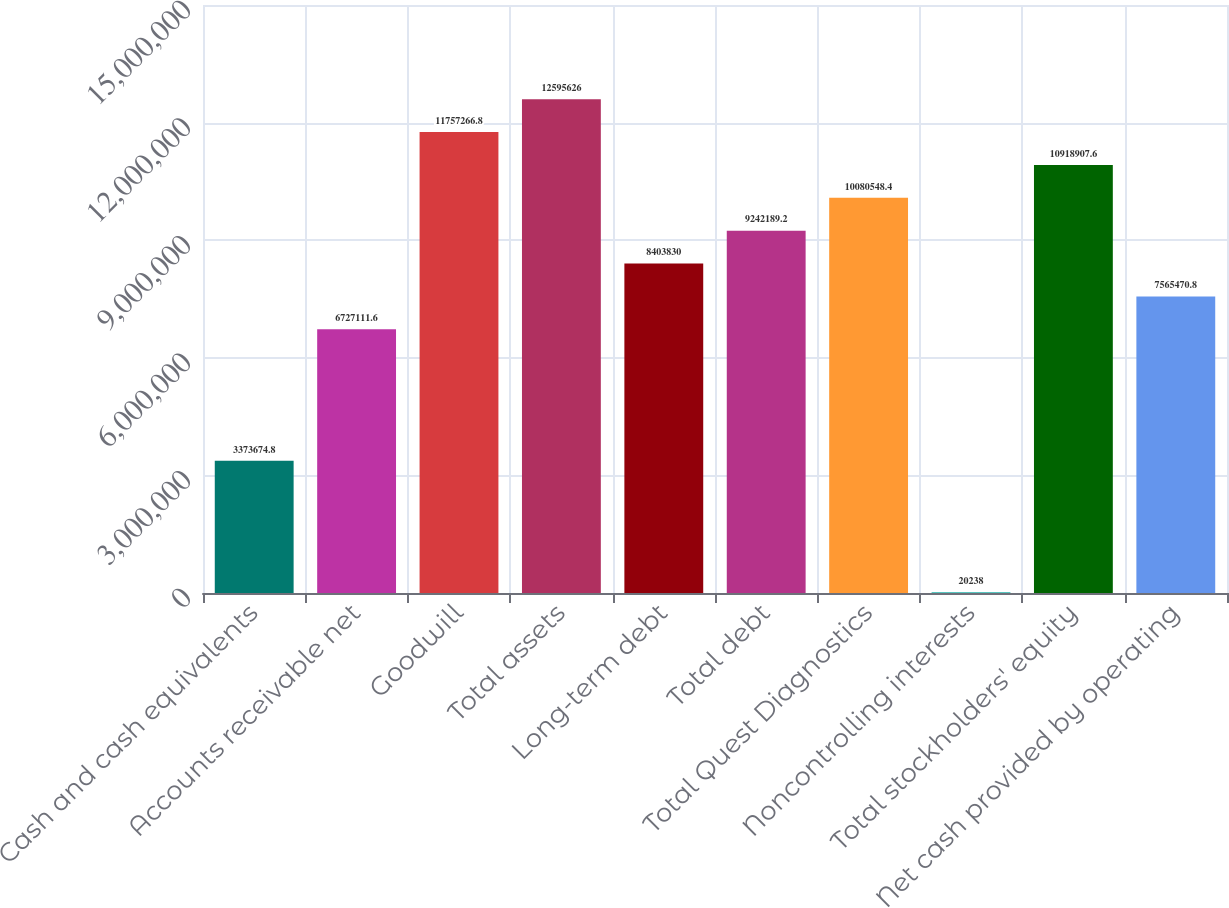<chart> <loc_0><loc_0><loc_500><loc_500><bar_chart><fcel>Cash and cash equivalents<fcel>Accounts receivable net<fcel>Goodwill<fcel>Total assets<fcel>Long-term debt<fcel>Total debt<fcel>Total Quest Diagnostics<fcel>Noncontrolling interests<fcel>Total stockholders' equity<fcel>Net cash provided by operating<nl><fcel>3.37367e+06<fcel>6.72711e+06<fcel>1.17573e+07<fcel>1.25956e+07<fcel>8.40383e+06<fcel>9.24219e+06<fcel>1.00805e+07<fcel>20238<fcel>1.09189e+07<fcel>7.56547e+06<nl></chart> 